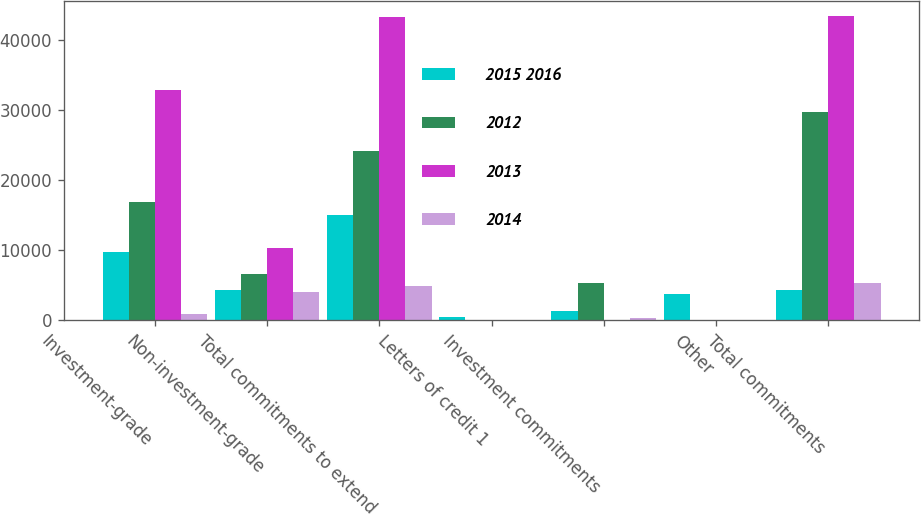Convert chart to OTSL. <chart><loc_0><loc_0><loc_500><loc_500><stacked_bar_chart><ecel><fcel>Investment-grade<fcel>Non-investment-grade<fcel>Total commitments to extend<fcel>Letters of credit 1<fcel>Investment commitments<fcel>Other<fcel>Total commitments<nl><fcel>2015 2016<fcel>9735<fcel>4339<fcel>15069<fcel>465<fcel>1359<fcel>3734<fcel>4339<nl><fcel>2012<fcel>16903<fcel>6590<fcel>24214<fcel>21<fcel>5387<fcel>102<fcel>29724<nl><fcel>2013<fcel>32960<fcel>10396<fcel>43356<fcel>10<fcel>20<fcel>54<fcel>43440<nl><fcel>2014<fcel>901<fcel>4087<fcel>4988<fcel>5<fcel>350<fcel>65<fcel>5408<nl></chart> 